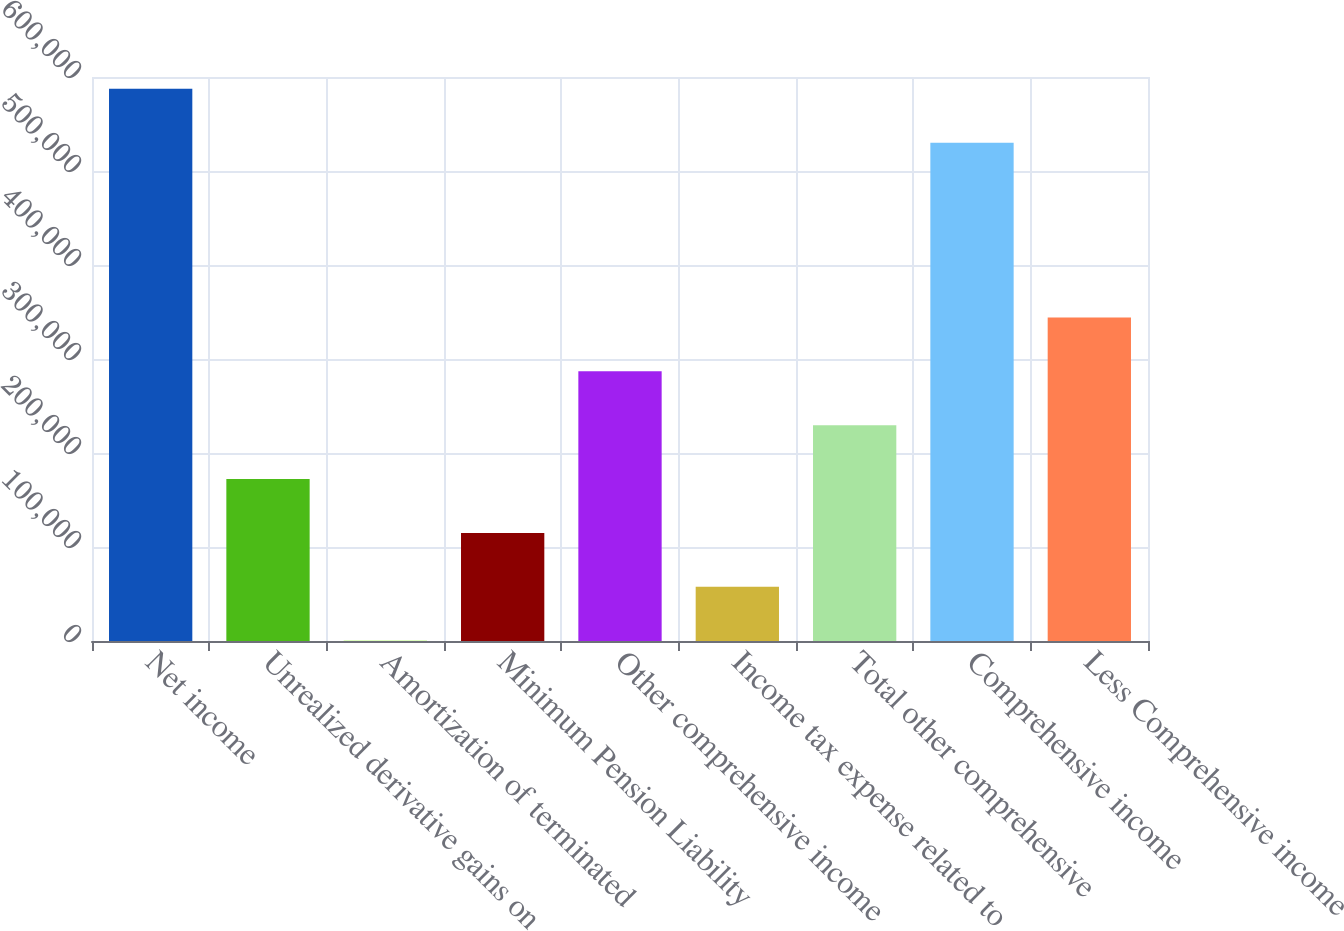Convert chart to OTSL. <chart><loc_0><loc_0><loc_500><loc_500><bar_chart><fcel>Net income<fcel>Unrealized derivative gains on<fcel>Amortization of terminated<fcel>Minimum Pension Liability<fcel>Other comprehensive income<fcel>Income tax expense related to<fcel>Total other comprehensive<fcel>Comprehensive income<fcel>Less Comprehensive income<nl><fcel>587380<fcel>172245<fcel>336<fcel>114942<fcel>286852<fcel>57639.1<fcel>229548<fcel>530077<fcel>344155<nl></chart> 